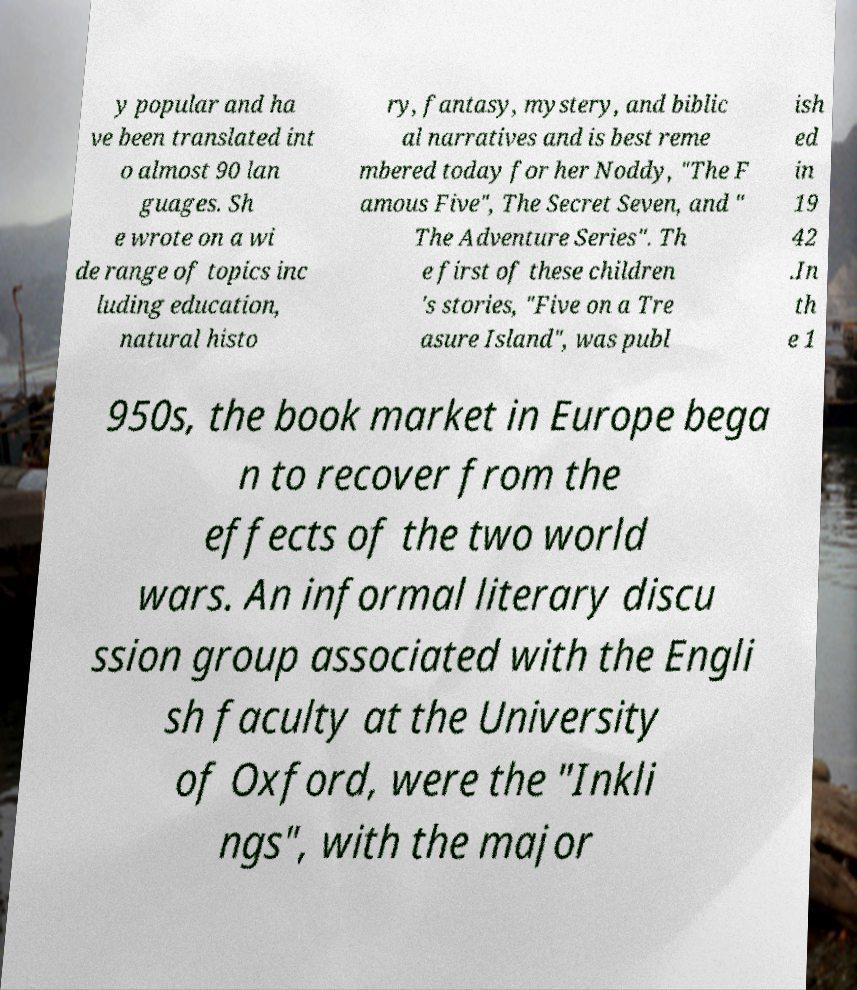What messages or text are displayed in this image? I need them in a readable, typed format. y popular and ha ve been translated int o almost 90 lan guages. Sh e wrote on a wi de range of topics inc luding education, natural histo ry, fantasy, mystery, and biblic al narratives and is best reme mbered today for her Noddy, "The F amous Five", The Secret Seven, and " The Adventure Series". Th e first of these children 's stories, "Five on a Tre asure Island", was publ ish ed in 19 42 .In th e 1 950s, the book market in Europe bega n to recover from the effects of the two world wars. An informal literary discu ssion group associated with the Engli sh faculty at the University of Oxford, were the "Inkli ngs", with the major 